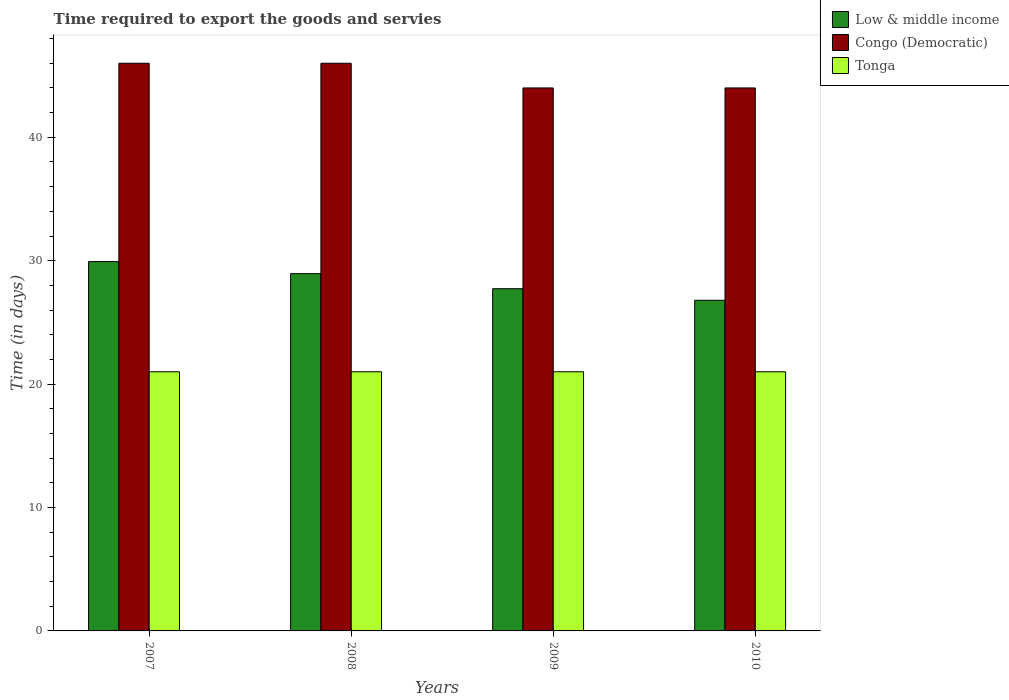How many bars are there on the 4th tick from the right?
Make the answer very short. 3. What is the label of the 3rd group of bars from the left?
Your response must be concise. 2009. In how many cases, is the number of bars for a given year not equal to the number of legend labels?
Give a very brief answer. 0. What is the number of days required to export the goods and services in Congo (Democratic) in 2007?
Give a very brief answer. 46. Across all years, what is the maximum number of days required to export the goods and services in Congo (Democratic)?
Provide a succinct answer. 46. Across all years, what is the minimum number of days required to export the goods and services in Tonga?
Your answer should be very brief. 21. In which year was the number of days required to export the goods and services in Tonga minimum?
Offer a terse response. 2007. What is the total number of days required to export the goods and services in Congo (Democratic) in the graph?
Make the answer very short. 180. What is the difference between the number of days required to export the goods and services in Low & middle income in 2008 and that in 2010?
Your answer should be compact. 2.16. What is the difference between the number of days required to export the goods and services in Low & middle income in 2007 and the number of days required to export the goods and services in Congo (Democratic) in 2008?
Your response must be concise. -16.07. What is the average number of days required to export the goods and services in Low & middle income per year?
Provide a short and direct response. 28.35. In the year 2009, what is the difference between the number of days required to export the goods and services in Tonga and number of days required to export the goods and services in Congo (Democratic)?
Your answer should be very brief. -23. In how many years, is the number of days required to export the goods and services in Congo (Democratic) greater than 24 days?
Provide a succinct answer. 4. What is the ratio of the number of days required to export the goods and services in Low & middle income in 2009 to that in 2010?
Make the answer very short. 1.03. Is the number of days required to export the goods and services in Tonga in 2007 less than that in 2008?
Provide a succinct answer. No. Is the difference between the number of days required to export the goods and services in Tonga in 2008 and 2009 greater than the difference between the number of days required to export the goods and services in Congo (Democratic) in 2008 and 2009?
Offer a terse response. No. What is the difference between the highest and the second highest number of days required to export the goods and services in Congo (Democratic)?
Offer a terse response. 0. What does the 3rd bar from the left in 2010 represents?
Keep it short and to the point. Tonga. What does the 2nd bar from the right in 2007 represents?
Your answer should be compact. Congo (Democratic). Is it the case that in every year, the sum of the number of days required to export the goods and services in Low & middle income and number of days required to export the goods and services in Congo (Democratic) is greater than the number of days required to export the goods and services in Tonga?
Make the answer very short. Yes. How many bars are there?
Give a very brief answer. 12. Are all the bars in the graph horizontal?
Your response must be concise. No. What is the difference between two consecutive major ticks on the Y-axis?
Offer a very short reply. 10. Are the values on the major ticks of Y-axis written in scientific E-notation?
Keep it short and to the point. No. Does the graph contain any zero values?
Provide a succinct answer. No. Does the graph contain grids?
Give a very brief answer. No. Where does the legend appear in the graph?
Provide a short and direct response. Top right. What is the title of the graph?
Provide a short and direct response. Time required to export the goods and servies. Does "Namibia" appear as one of the legend labels in the graph?
Provide a short and direct response. No. What is the label or title of the X-axis?
Provide a short and direct response. Years. What is the label or title of the Y-axis?
Your answer should be very brief. Time (in days). What is the Time (in days) in Low & middle income in 2007?
Keep it short and to the point. 29.93. What is the Time (in days) of Congo (Democratic) in 2007?
Your answer should be very brief. 46. What is the Time (in days) of Tonga in 2007?
Provide a short and direct response. 21. What is the Time (in days) in Low & middle income in 2008?
Make the answer very short. 28.95. What is the Time (in days) in Low & middle income in 2009?
Provide a succinct answer. 27.73. What is the Time (in days) of Congo (Democratic) in 2009?
Keep it short and to the point. 44. What is the Time (in days) in Low & middle income in 2010?
Your response must be concise. 26.79. Across all years, what is the maximum Time (in days) in Low & middle income?
Keep it short and to the point. 29.93. Across all years, what is the maximum Time (in days) in Congo (Democratic)?
Your response must be concise. 46. Across all years, what is the minimum Time (in days) in Low & middle income?
Give a very brief answer. 26.79. Across all years, what is the minimum Time (in days) in Tonga?
Your response must be concise. 21. What is the total Time (in days) in Low & middle income in the graph?
Make the answer very short. 113.4. What is the total Time (in days) in Congo (Democratic) in the graph?
Your response must be concise. 180. What is the difference between the Time (in days) in Low & middle income in 2007 and that in 2008?
Offer a very short reply. 0.98. What is the difference between the Time (in days) in Congo (Democratic) in 2007 and that in 2008?
Keep it short and to the point. 0. What is the difference between the Time (in days) of Tonga in 2007 and that in 2008?
Keep it short and to the point. 0. What is the difference between the Time (in days) of Low & middle income in 2007 and that in 2009?
Provide a succinct answer. 2.2. What is the difference between the Time (in days) in Tonga in 2007 and that in 2009?
Make the answer very short. 0. What is the difference between the Time (in days) in Low & middle income in 2007 and that in 2010?
Your answer should be compact. 3.13. What is the difference between the Time (in days) in Tonga in 2007 and that in 2010?
Provide a succinct answer. 0. What is the difference between the Time (in days) in Low & middle income in 2008 and that in 2009?
Your answer should be compact. 1.22. What is the difference between the Time (in days) in Congo (Democratic) in 2008 and that in 2009?
Offer a terse response. 2. What is the difference between the Time (in days) in Tonga in 2008 and that in 2009?
Your answer should be compact. 0. What is the difference between the Time (in days) in Low & middle income in 2008 and that in 2010?
Ensure brevity in your answer.  2.16. What is the difference between the Time (in days) in Congo (Democratic) in 2008 and that in 2010?
Your answer should be compact. 2. What is the difference between the Time (in days) in Low & middle income in 2009 and that in 2010?
Your response must be concise. 0.94. What is the difference between the Time (in days) of Congo (Democratic) in 2009 and that in 2010?
Give a very brief answer. 0. What is the difference between the Time (in days) of Tonga in 2009 and that in 2010?
Ensure brevity in your answer.  0. What is the difference between the Time (in days) in Low & middle income in 2007 and the Time (in days) in Congo (Democratic) in 2008?
Provide a short and direct response. -16.07. What is the difference between the Time (in days) in Low & middle income in 2007 and the Time (in days) in Tonga in 2008?
Keep it short and to the point. 8.93. What is the difference between the Time (in days) in Low & middle income in 2007 and the Time (in days) in Congo (Democratic) in 2009?
Make the answer very short. -14.07. What is the difference between the Time (in days) in Low & middle income in 2007 and the Time (in days) in Tonga in 2009?
Provide a succinct answer. 8.93. What is the difference between the Time (in days) of Congo (Democratic) in 2007 and the Time (in days) of Tonga in 2009?
Ensure brevity in your answer.  25. What is the difference between the Time (in days) in Low & middle income in 2007 and the Time (in days) in Congo (Democratic) in 2010?
Provide a succinct answer. -14.07. What is the difference between the Time (in days) of Low & middle income in 2007 and the Time (in days) of Tonga in 2010?
Make the answer very short. 8.93. What is the difference between the Time (in days) in Congo (Democratic) in 2007 and the Time (in days) in Tonga in 2010?
Offer a very short reply. 25. What is the difference between the Time (in days) of Low & middle income in 2008 and the Time (in days) of Congo (Democratic) in 2009?
Make the answer very short. -15.05. What is the difference between the Time (in days) of Low & middle income in 2008 and the Time (in days) of Tonga in 2009?
Provide a short and direct response. 7.95. What is the difference between the Time (in days) in Congo (Democratic) in 2008 and the Time (in days) in Tonga in 2009?
Your response must be concise. 25. What is the difference between the Time (in days) in Low & middle income in 2008 and the Time (in days) in Congo (Democratic) in 2010?
Make the answer very short. -15.05. What is the difference between the Time (in days) in Low & middle income in 2008 and the Time (in days) in Tonga in 2010?
Provide a succinct answer. 7.95. What is the difference between the Time (in days) in Congo (Democratic) in 2008 and the Time (in days) in Tonga in 2010?
Your response must be concise. 25. What is the difference between the Time (in days) in Low & middle income in 2009 and the Time (in days) in Congo (Democratic) in 2010?
Make the answer very short. -16.27. What is the difference between the Time (in days) of Low & middle income in 2009 and the Time (in days) of Tonga in 2010?
Provide a short and direct response. 6.73. What is the difference between the Time (in days) in Congo (Democratic) in 2009 and the Time (in days) in Tonga in 2010?
Provide a succinct answer. 23. What is the average Time (in days) of Low & middle income per year?
Make the answer very short. 28.35. In the year 2007, what is the difference between the Time (in days) in Low & middle income and Time (in days) in Congo (Democratic)?
Give a very brief answer. -16.07. In the year 2007, what is the difference between the Time (in days) in Low & middle income and Time (in days) in Tonga?
Make the answer very short. 8.93. In the year 2008, what is the difference between the Time (in days) of Low & middle income and Time (in days) of Congo (Democratic)?
Offer a terse response. -17.05. In the year 2008, what is the difference between the Time (in days) of Low & middle income and Time (in days) of Tonga?
Your answer should be very brief. 7.95. In the year 2008, what is the difference between the Time (in days) in Congo (Democratic) and Time (in days) in Tonga?
Give a very brief answer. 25. In the year 2009, what is the difference between the Time (in days) of Low & middle income and Time (in days) of Congo (Democratic)?
Your answer should be very brief. -16.27. In the year 2009, what is the difference between the Time (in days) of Low & middle income and Time (in days) of Tonga?
Give a very brief answer. 6.73. In the year 2010, what is the difference between the Time (in days) in Low & middle income and Time (in days) in Congo (Democratic)?
Your response must be concise. -17.21. In the year 2010, what is the difference between the Time (in days) of Low & middle income and Time (in days) of Tonga?
Offer a very short reply. 5.79. In the year 2010, what is the difference between the Time (in days) of Congo (Democratic) and Time (in days) of Tonga?
Your answer should be compact. 23. What is the ratio of the Time (in days) in Low & middle income in 2007 to that in 2008?
Your response must be concise. 1.03. What is the ratio of the Time (in days) of Tonga in 2007 to that in 2008?
Your answer should be compact. 1. What is the ratio of the Time (in days) in Low & middle income in 2007 to that in 2009?
Provide a succinct answer. 1.08. What is the ratio of the Time (in days) in Congo (Democratic) in 2007 to that in 2009?
Your answer should be very brief. 1.05. What is the ratio of the Time (in days) in Low & middle income in 2007 to that in 2010?
Your response must be concise. 1.12. What is the ratio of the Time (in days) in Congo (Democratic) in 2007 to that in 2010?
Give a very brief answer. 1.05. What is the ratio of the Time (in days) of Tonga in 2007 to that in 2010?
Provide a succinct answer. 1. What is the ratio of the Time (in days) in Low & middle income in 2008 to that in 2009?
Offer a very short reply. 1.04. What is the ratio of the Time (in days) in Congo (Democratic) in 2008 to that in 2009?
Provide a short and direct response. 1.05. What is the ratio of the Time (in days) of Low & middle income in 2008 to that in 2010?
Your answer should be very brief. 1.08. What is the ratio of the Time (in days) of Congo (Democratic) in 2008 to that in 2010?
Give a very brief answer. 1.05. What is the ratio of the Time (in days) of Low & middle income in 2009 to that in 2010?
Give a very brief answer. 1.03. What is the difference between the highest and the second highest Time (in days) of Congo (Democratic)?
Ensure brevity in your answer.  0. What is the difference between the highest and the second highest Time (in days) of Tonga?
Your answer should be compact. 0. What is the difference between the highest and the lowest Time (in days) of Low & middle income?
Make the answer very short. 3.13. What is the difference between the highest and the lowest Time (in days) of Congo (Democratic)?
Your answer should be very brief. 2. What is the difference between the highest and the lowest Time (in days) in Tonga?
Provide a short and direct response. 0. 